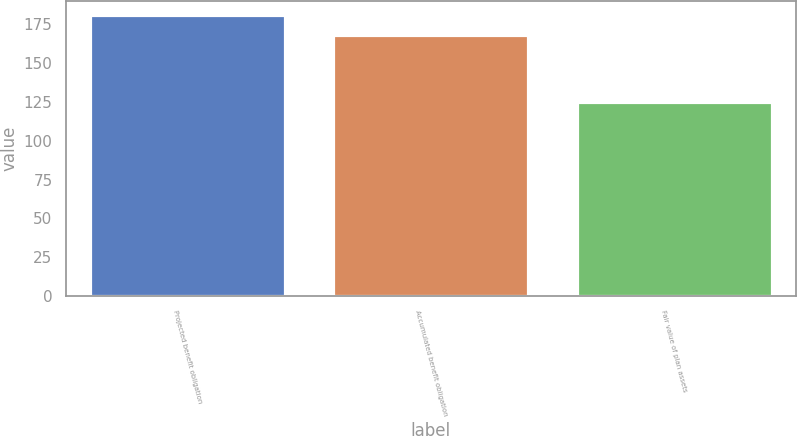Convert chart. <chart><loc_0><loc_0><loc_500><loc_500><bar_chart><fcel>Projected benefit obligation<fcel>Accumulated benefit obligation<fcel>Fair value of plan assets<nl><fcel>181<fcel>168<fcel>125<nl></chart> 